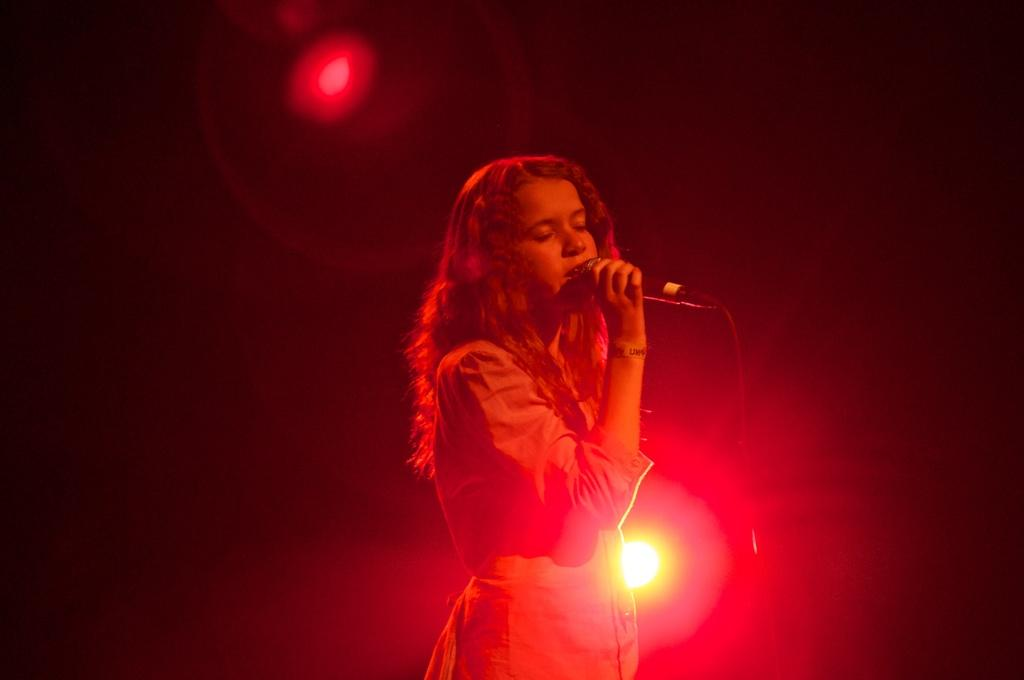Who is the main subject in the image? There is a woman in the image. What is the woman holding in the image? The woman is holding a microphone. Can you describe the lighting in the image? There is a light focus in the image. What is the color of the background in the image? The background of the image is dark. What type of volcano can be seen erupting in the background of the image? There is no volcano present in the image; the background is dark. How does the clam contribute to the woman's performance in the image? There is no clam present in the image; the woman is holding a microphone. 